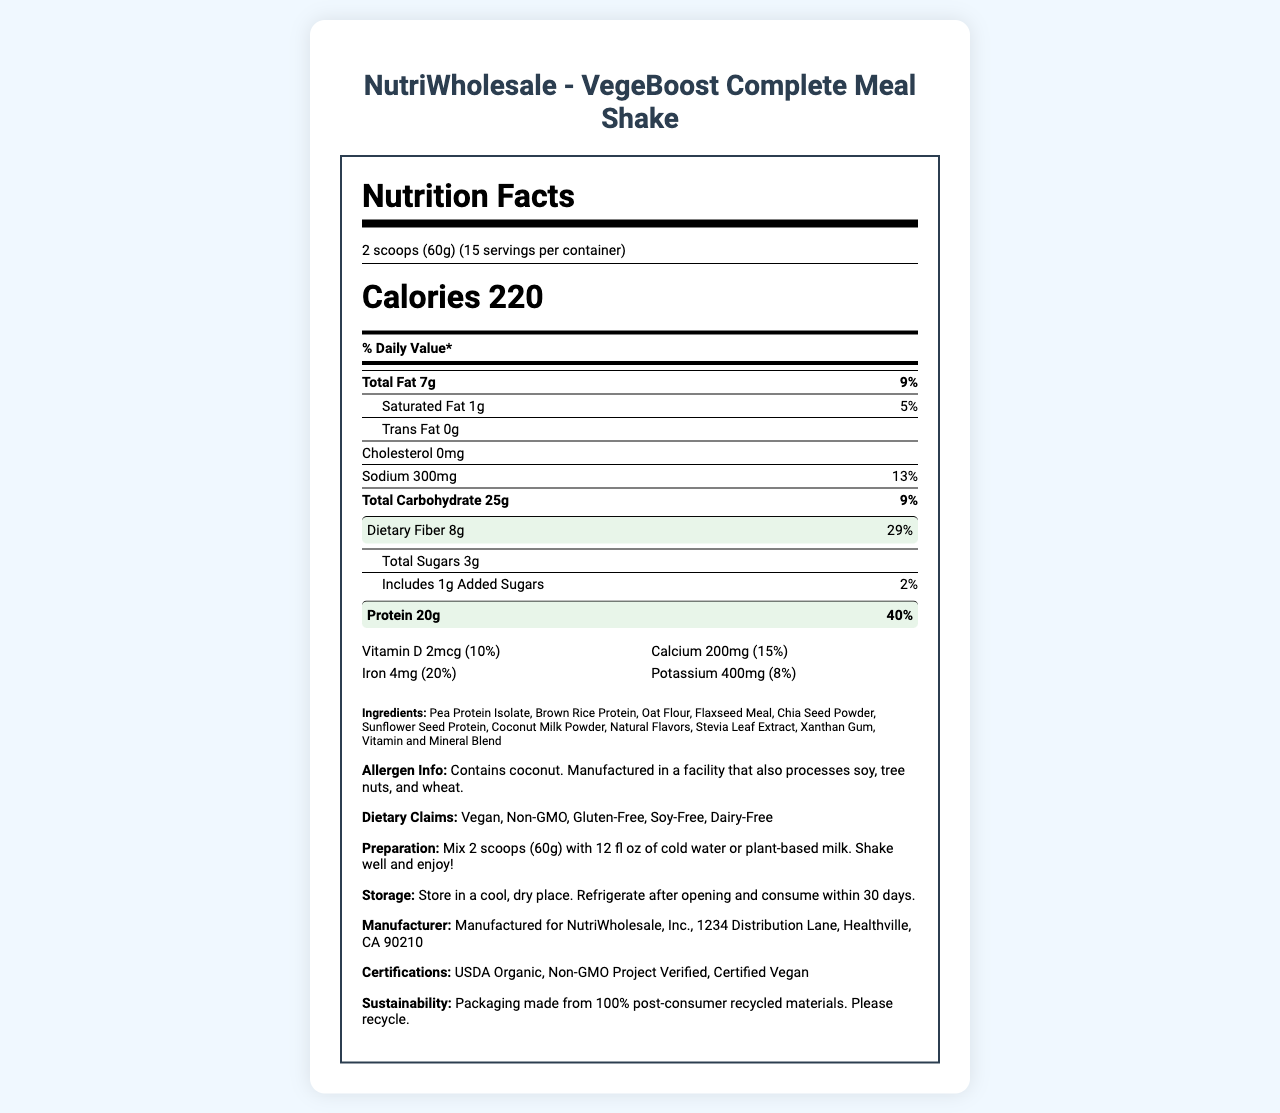what is the serving size of VegeBoost Complete Meal Shake? The serving size is listed near the top of the nutrition label in the serving information section.
Answer: 2 scoops (60g) How much dietary fiber does one serving provide? The dietary fiber content per serving is highlighted in the nutrient section of the nutrition label.
Answer: 8g What is the daily value percentage for protein? The daily value percentage for protein is listed alongside the amount of protein, in bold and highlighted.
Answer: 40% What are the total carbohydrates per serving? The total carbohydrate content per serving is provided in the "Total Carbohydrate" section of the nutrition label.
Answer: 25g How many calories are there in one serving? The calorie content per serving is prominently displayed near the top of the nutrition label.
Answer: 220 What allergens does the product contain? A. Soy, B. Tree nuts, C. Coconut, D. Wheat The allergen information section states that the product contains coconut.
Answer: C. Coconut Which of the following is NOT a dietary claim for the product? A. Vegan, B. Non-GMO, C. High Protein, D. Gluten-Free The dietary claims listed are "Vegan", "Non-GMO", "Gluten-Free", "Soy-Free", and "Dairy-Free".
Answer: C. High Protein Is the product gluten-free? The dietary claims section lists "Gluten-free" as one of the product's attributes.
Answer: Yes Summarize the main nutritional highlights of VegeBoost Complete Meal Shake. The nutritional highlights emphasize the fiber and protein content as well as caloric value, alongside highlighting its dietary claims and nutrient additions.
Answer: The VegeBoost Complete Meal Shake provides a balanced source of nutrition with significant fiber (8g, 29% DV) and protein (20g, 40% DV) content per serving. It is vegan, non-GMO, and gluten-free, with various added vitamins and minerals. Each serving also contains 220 calories and 25g of carbohydrates. What is the exact weight of one serving in grams? The serving weight is specified in the serving size section of the nutrition label.
Answer: 60 grams What vitamins and minerals show a daily value contribution of 30% or more? This information can be found in the vitamins and minerals section, where various nutrients and their daily value percentages are listed.
Answer: Riboflavin (30%), Vitamin B6 (30%), Vitamin B12 (50%), Biotin (100%), Chromium (35%), Molybdenum (35%) Is there information provided on how the product should be stored? The storage instructions indicate that the product should be stored in a cool, dry place, refrigerated after opening, and consumed within 30 days.
Answer: Yes What is the manufacturing address of the product? The manufacturer's information is listed at the bottom of the nutrition label.
Answer: Manufactured for NutriWholesale, Inc., 1234 Distribution Lane, Healthville, CA 90210 What percentage of the daily value does total fat represent? The daily value percentage for total fat is shown next to the amount of total fat.
Answer: 9% Are there any indications that the product contains artificial flavors? The ingredient list mentions natural flavors but does not mention artificial flavors.
Answer: No What amount of calcium does the product provide per serving? The calcium content per serving is indicated in the vitamins and minerals section.
Answer: 200mg Is there any information on the product's environmental sustainability credentials? The sustainability information section states that the packaging is made from 100% post-consumer recycled materials and encourages recycling.
Answer: Yes What is the preparation instruction for the VegeBoost Complete Meal Shake? The preparation instructions are listed under the 'Preparation' section of the document.
Answer: Mix 2 scoops (60g) with 12 fl oz of cold water or plant-based milk. Shake well and enjoy! What is the company's claim about the product's impact on soy allergens? The allergen information section of the label contains this information.
Answer: Contains coconut. Manufactured in a facility that also processes soy, tree nuts, and wheat. How does the fiber content of VegeBoost Complete Meal Shake compare to the protein content? Both fiber and protein content are highlighted in the nutrition label, with the protein content being notably higher.
Answer: While each serving provides 8g of dietary fiber (29% DV), it also offers a higher protein content of 20g (40% DV). What is the main ingredient listed in the product? The ingredients section lists Pea Protein Isolate as the first ingredient, indicating it is the main ingredient in the product.
Answer: Pea Protein Isolate How many servings are there in one container of VegeBoost Complete Meal Shake? The servings per container are mentioned at the beginning of the nutritional information.
Answer: 15 servings Why is molybdenum important and what foods are good sources of it? The document does not provide details on the importance of molybdenum or its food sources.
Answer: Not enough information 